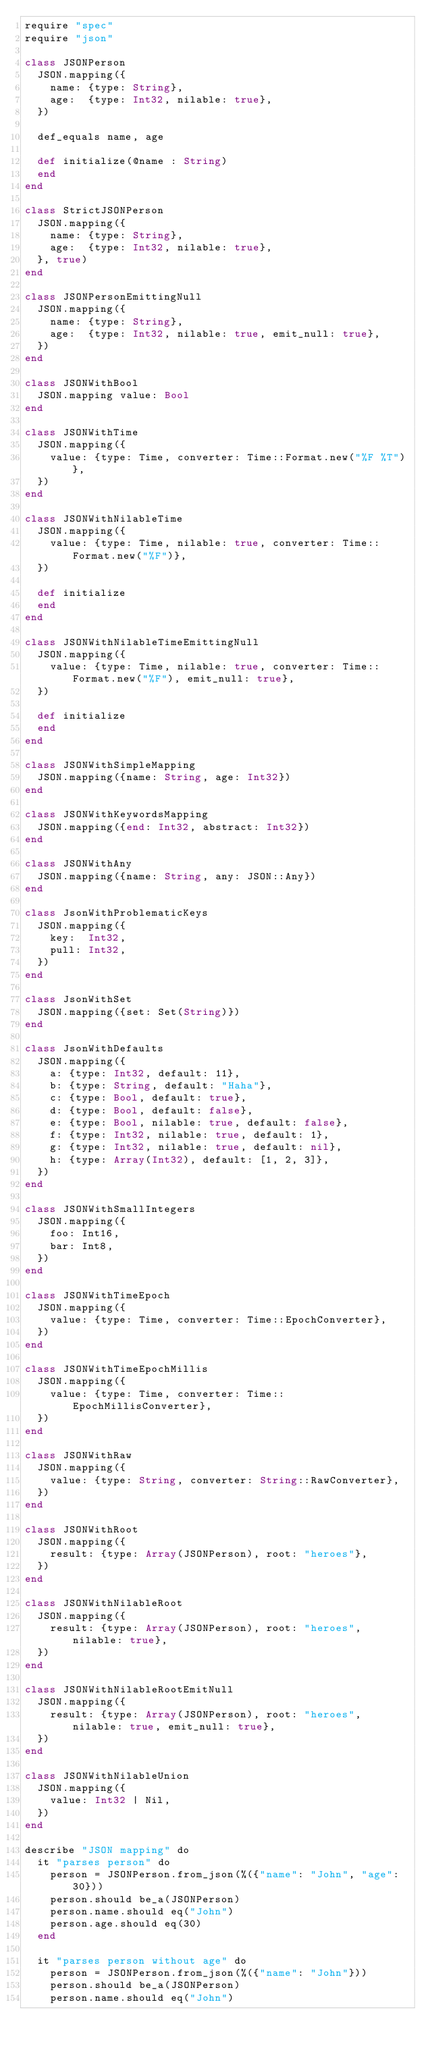Convert code to text. <code><loc_0><loc_0><loc_500><loc_500><_Crystal_>require "spec"
require "json"

class JSONPerson
  JSON.mapping({
    name: {type: String},
    age:  {type: Int32, nilable: true},
  })

  def_equals name, age

  def initialize(@name : String)
  end
end

class StrictJSONPerson
  JSON.mapping({
    name: {type: String},
    age:  {type: Int32, nilable: true},
  }, true)
end

class JSONPersonEmittingNull
  JSON.mapping({
    name: {type: String},
    age:  {type: Int32, nilable: true, emit_null: true},
  })
end

class JSONWithBool
  JSON.mapping value: Bool
end

class JSONWithTime
  JSON.mapping({
    value: {type: Time, converter: Time::Format.new("%F %T")},
  })
end

class JSONWithNilableTime
  JSON.mapping({
    value: {type: Time, nilable: true, converter: Time::Format.new("%F")},
  })

  def initialize
  end
end

class JSONWithNilableTimeEmittingNull
  JSON.mapping({
    value: {type: Time, nilable: true, converter: Time::Format.new("%F"), emit_null: true},
  })

  def initialize
  end
end

class JSONWithSimpleMapping
  JSON.mapping({name: String, age: Int32})
end

class JSONWithKeywordsMapping
  JSON.mapping({end: Int32, abstract: Int32})
end

class JSONWithAny
  JSON.mapping({name: String, any: JSON::Any})
end

class JsonWithProblematicKeys
  JSON.mapping({
    key:  Int32,
    pull: Int32,
  })
end

class JsonWithSet
  JSON.mapping({set: Set(String)})
end

class JsonWithDefaults
  JSON.mapping({
    a: {type: Int32, default: 11},
    b: {type: String, default: "Haha"},
    c: {type: Bool, default: true},
    d: {type: Bool, default: false},
    e: {type: Bool, nilable: true, default: false},
    f: {type: Int32, nilable: true, default: 1},
    g: {type: Int32, nilable: true, default: nil},
    h: {type: Array(Int32), default: [1, 2, 3]},
  })
end

class JSONWithSmallIntegers
  JSON.mapping({
    foo: Int16,
    bar: Int8,
  })
end

class JSONWithTimeEpoch
  JSON.mapping({
    value: {type: Time, converter: Time::EpochConverter},
  })
end

class JSONWithTimeEpochMillis
  JSON.mapping({
    value: {type: Time, converter: Time::EpochMillisConverter},
  })
end

class JSONWithRaw
  JSON.mapping({
    value: {type: String, converter: String::RawConverter},
  })
end

class JSONWithRoot
  JSON.mapping({
    result: {type: Array(JSONPerson), root: "heroes"},
  })
end

class JSONWithNilableRoot
  JSON.mapping({
    result: {type: Array(JSONPerson), root: "heroes", nilable: true},
  })
end

class JSONWithNilableRootEmitNull
  JSON.mapping({
    result: {type: Array(JSONPerson), root: "heroes", nilable: true, emit_null: true},
  })
end

class JSONWithNilableUnion
  JSON.mapping({
    value: Int32 | Nil,
  })
end

describe "JSON mapping" do
  it "parses person" do
    person = JSONPerson.from_json(%({"name": "John", "age": 30}))
    person.should be_a(JSONPerson)
    person.name.should eq("John")
    person.age.should eq(30)
  end

  it "parses person without age" do
    person = JSONPerson.from_json(%({"name": "John"}))
    person.should be_a(JSONPerson)
    person.name.should eq("John")</code> 